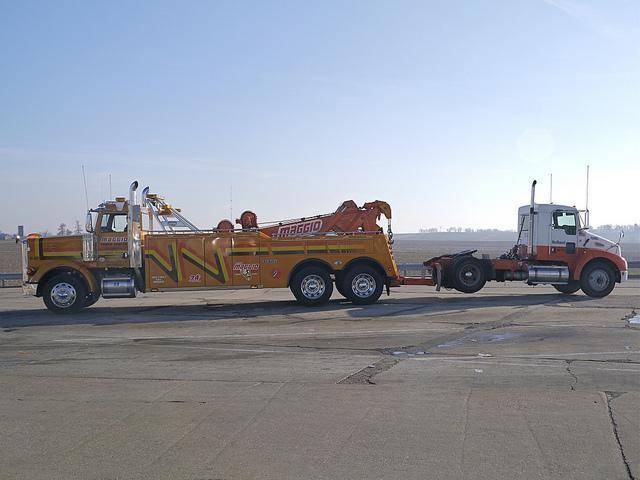How many tires on are the vehicle doing the hauling?
Give a very brief answer. 6. How many women are in this group?
Give a very brief answer. 0. 